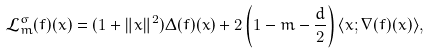Convert formula to latex. <formula><loc_0><loc_0><loc_500><loc_500>\mathcal { L } ^ { \sigma } _ { m } ( f ) ( x ) = ( 1 + \| x \| ^ { 2 } ) \Delta ( f ) ( x ) + 2 \left ( 1 - m - \frac { d } { 2 } \right ) \langle x ; \nabla ( f ) ( x ) \rangle ,</formula> 